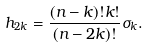<formula> <loc_0><loc_0><loc_500><loc_500>h _ { 2 k } = \frac { ( n - k ) ! k ! } { ( n - 2 k ) ! } \sigma _ { k } .</formula> 